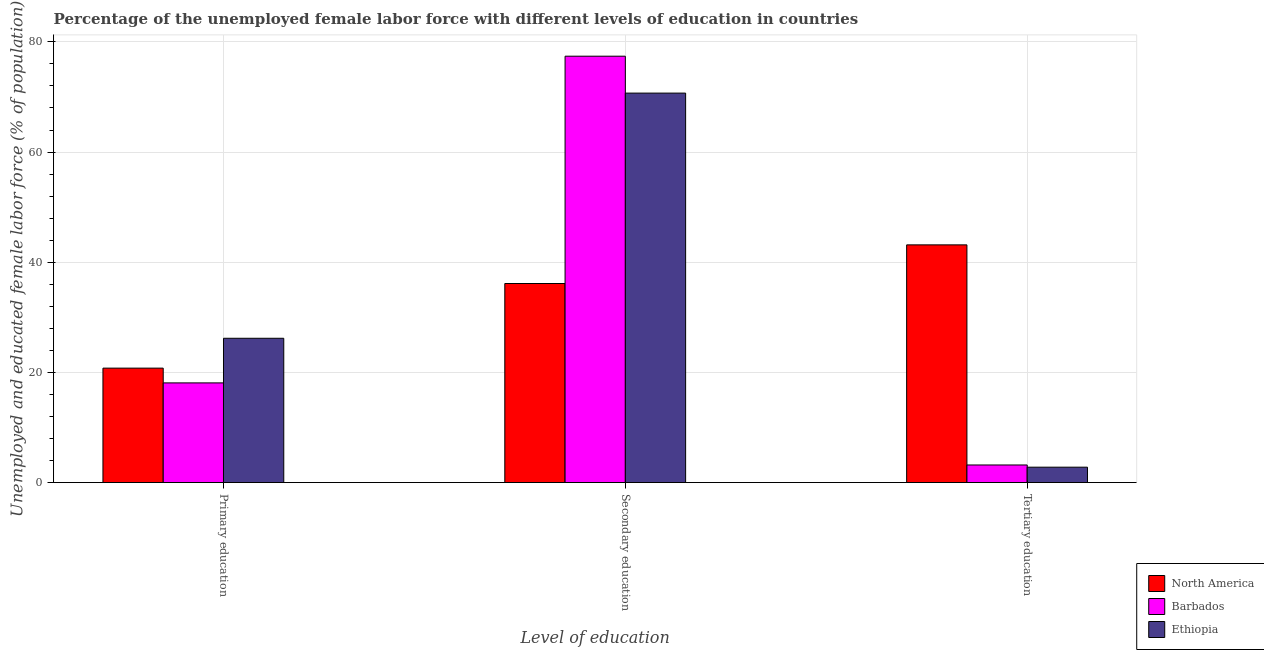How many groups of bars are there?
Your answer should be very brief. 3. How many bars are there on the 1st tick from the left?
Ensure brevity in your answer.  3. What is the label of the 3rd group of bars from the left?
Provide a short and direct response. Tertiary education. What is the percentage of female labor force who received tertiary education in North America?
Offer a very short reply. 43.15. Across all countries, what is the maximum percentage of female labor force who received tertiary education?
Give a very brief answer. 43.15. Across all countries, what is the minimum percentage of female labor force who received primary education?
Keep it short and to the point. 18.1. In which country was the percentage of female labor force who received secondary education maximum?
Keep it short and to the point. Barbados. In which country was the percentage of female labor force who received primary education minimum?
Offer a very short reply. Barbados. What is the total percentage of female labor force who received secondary education in the graph?
Your response must be concise. 184.24. What is the difference between the percentage of female labor force who received secondary education in Barbados and that in Ethiopia?
Make the answer very short. 6.7. What is the difference between the percentage of female labor force who received secondary education in Barbados and the percentage of female labor force who received primary education in Ethiopia?
Make the answer very short. 51.2. What is the average percentage of female labor force who received tertiary education per country?
Offer a very short reply. 16.38. What is the difference between the percentage of female labor force who received tertiary education and percentage of female labor force who received primary education in North America?
Offer a very short reply. 22.37. In how many countries, is the percentage of female labor force who received primary education greater than 32 %?
Your response must be concise. 0. What is the ratio of the percentage of female labor force who received secondary education in Ethiopia to that in Barbados?
Provide a short and direct response. 0.91. What is the difference between the highest and the second highest percentage of female labor force who received primary education?
Offer a terse response. 5.42. What is the difference between the highest and the lowest percentage of female labor force who received primary education?
Your answer should be compact. 8.1. In how many countries, is the percentage of female labor force who received tertiary education greater than the average percentage of female labor force who received tertiary education taken over all countries?
Give a very brief answer. 1. Is the sum of the percentage of female labor force who received tertiary education in North America and Ethiopia greater than the maximum percentage of female labor force who received primary education across all countries?
Your response must be concise. Yes. What does the 2nd bar from the right in Primary education represents?
Offer a terse response. Barbados. How many bars are there?
Provide a short and direct response. 9. Are all the bars in the graph horizontal?
Keep it short and to the point. No. Does the graph contain grids?
Your response must be concise. Yes. How many legend labels are there?
Provide a succinct answer. 3. What is the title of the graph?
Give a very brief answer. Percentage of the unemployed female labor force with different levels of education in countries. Does "Burundi" appear as one of the legend labels in the graph?
Give a very brief answer. No. What is the label or title of the X-axis?
Make the answer very short. Level of education. What is the label or title of the Y-axis?
Your answer should be very brief. Unemployed and educated female labor force (% of population). What is the Unemployed and educated female labor force (% of population) of North America in Primary education?
Provide a succinct answer. 20.78. What is the Unemployed and educated female labor force (% of population) in Barbados in Primary education?
Your answer should be compact. 18.1. What is the Unemployed and educated female labor force (% of population) of Ethiopia in Primary education?
Provide a short and direct response. 26.2. What is the Unemployed and educated female labor force (% of population) in North America in Secondary education?
Provide a short and direct response. 36.14. What is the Unemployed and educated female labor force (% of population) in Barbados in Secondary education?
Keep it short and to the point. 77.4. What is the Unemployed and educated female labor force (% of population) in Ethiopia in Secondary education?
Your answer should be compact. 70.7. What is the Unemployed and educated female labor force (% of population) in North America in Tertiary education?
Offer a terse response. 43.15. What is the Unemployed and educated female labor force (% of population) in Barbados in Tertiary education?
Your response must be concise. 3.2. What is the Unemployed and educated female labor force (% of population) in Ethiopia in Tertiary education?
Give a very brief answer. 2.8. Across all Level of education, what is the maximum Unemployed and educated female labor force (% of population) in North America?
Your response must be concise. 43.15. Across all Level of education, what is the maximum Unemployed and educated female labor force (% of population) in Barbados?
Your response must be concise. 77.4. Across all Level of education, what is the maximum Unemployed and educated female labor force (% of population) of Ethiopia?
Ensure brevity in your answer.  70.7. Across all Level of education, what is the minimum Unemployed and educated female labor force (% of population) of North America?
Keep it short and to the point. 20.78. Across all Level of education, what is the minimum Unemployed and educated female labor force (% of population) in Barbados?
Your answer should be very brief. 3.2. Across all Level of education, what is the minimum Unemployed and educated female labor force (% of population) in Ethiopia?
Ensure brevity in your answer.  2.8. What is the total Unemployed and educated female labor force (% of population) of North America in the graph?
Your response must be concise. 100.07. What is the total Unemployed and educated female labor force (% of population) of Barbados in the graph?
Give a very brief answer. 98.7. What is the total Unemployed and educated female labor force (% of population) of Ethiopia in the graph?
Your answer should be compact. 99.7. What is the difference between the Unemployed and educated female labor force (% of population) of North America in Primary education and that in Secondary education?
Offer a very short reply. -15.36. What is the difference between the Unemployed and educated female labor force (% of population) of Barbados in Primary education and that in Secondary education?
Provide a short and direct response. -59.3. What is the difference between the Unemployed and educated female labor force (% of population) in Ethiopia in Primary education and that in Secondary education?
Your answer should be compact. -44.5. What is the difference between the Unemployed and educated female labor force (% of population) in North America in Primary education and that in Tertiary education?
Provide a succinct answer. -22.37. What is the difference between the Unemployed and educated female labor force (% of population) in Ethiopia in Primary education and that in Tertiary education?
Keep it short and to the point. 23.4. What is the difference between the Unemployed and educated female labor force (% of population) of North America in Secondary education and that in Tertiary education?
Ensure brevity in your answer.  -7.01. What is the difference between the Unemployed and educated female labor force (% of population) in Barbados in Secondary education and that in Tertiary education?
Your answer should be very brief. 74.2. What is the difference between the Unemployed and educated female labor force (% of population) of Ethiopia in Secondary education and that in Tertiary education?
Provide a succinct answer. 67.9. What is the difference between the Unemployed and educated female labor force (% of population) of North America in Primary education and the Unemployed and educated female labor force (% of population) of Barbados in Secondary education?
Make the answer very short. -56.62. What is the difference between the Unemployed and educated female labor force (% of population) of North America in Primary education and the Unemployed and educated female labor force (% of population) of Ethiopia in Secondary education?
Your answer should be compact. -49.92. What is the difference between the Unemployed and educated female labor force (% of population) of Barbados in Primary education and the Unemployed and educated female labor force (% of population) of Ethiopia in Secondary education?
Offer a terse response. -52.6. What is the difference between the Unemployed and educated female labor force (% of population) of North America in Primary education and the Unemployed and educated female labor force (% of population) of Barbados in Tertiary education?
Offer a terse response. 17.58. What is the difference between the Unemployed and educated female labor force (% of population) of North America in Primary education and the Unemployed and educated female labor force (% of population) of Ethiopia in Tertiary education?
Your answer should be very brief. 17.98. What is the difference between the Unemployed and educated female labor force (% of population) of Barbados in Primary education and the Unemployed and educated female labor force (% of population) of Ethiopia in Tertiary education?
Your answer should be very brief. 15.3. What is the difference between the Unemployed and educated female labor force (% of population) in North America in Secondary education and the Unemployed and educated female labor force (% of population) in Barbados in Tertiary education?
Ensure brevity in your answer.  32.94. What is the difference between the Unemployed and educated female labor force (% of population) of North America in Secondary education and the Unemployed and educated female labor force (% of population) of Ethiopia in Tertiary education?
Offer a terse response. 33.34. What is the difference between the Unemployed and educated female labor force (% of population) of Barbados in Secondary education and the Unemployed and educated female labor force (% of population) of Ethiopia in Tertiary education?
Your answer should be compact. 74.6. What is the average Unemployed and educated female labor force (% of population) of North America per Level of education?
Ensure brevity in your answer.  33.36. What is the average Unemployed and educated female labor force (% of population) in Barbados per Level of education?
Give a very brief answer. 32.9. What is the average Unemployed and educated female labor force (% of population) of Ethiopia per Level of education?
Offer a terse response. 33.23. What is the difference between the Unemployed and educated female labor force (% of population) in North America and Unemployed and educated female labor force (% of population) in Barbados in Primary education?
Provide a succinct answer. 2.68. What is the difference between the Unemployed and educated female labor force (% of population) in North America and Unemployed and educated female labor force (% of population) in Ethiopia in Primary education?
Offer a very short reply. -5.42. What is the difference between the Unemployed and educated female labor force (% of population) in Barbados and Unemployed and educated female labor force (% of population) in Ethiopia in Primary education?
Give a very brief answer. -8.1. What is the difference between the Unemployed and educated female labor force (% of population) of North America and Unemployed and educated female labor force (% of population) of Barbados in Secondary education?
Ensure brevity in your answer.  -41.26. What is the difference between the Unemployed and educated female labor force (% of population) of North America and Unemployed and educated female labor force (% of population) of Ethiopia in Secondary education?
Give a very brief answer. -34.56. What is the difference between the Unemployed and educated female labor force (% of population) in North America and Unemployed and educated female labor force (% of population) in Barbados in Tertiary education?
Offer a very short reply. 39.95. What is the difference between the Unemployed and educated female labor force (% of population) of North America and Unemployed and educated female labor force (% of population) of Ethiopia in Tertiary education?
Offer a very short reply. 40.35. What is the difference between the Unemployed and educated female labor force (% of population) of Barbados and Unemployed and educated female labor force (% of population) of Ethiopia in Tertiary education?
Give a very brief answer. 0.4. What is the ratio of the Unemployed and educated female labor force (% of population) in North America in Primary education to that in Secondary education?
Provide a short and direct response. 0.57. What is the ratio of the Unemployed and educated female labor force (% of population) in Barbados in Primary education to that in Secondary education?
Make the answer very short. 0.23. What is the ratio of the Unemployed and educated female labor force (% of population) in Ethiopia in Primary education to that in Secondary education?
Ensure brevity in your answer.  0.37. What is the ratio of the Unemployed and educated female labor force (% of population) in North America in Primary education to that in Tertiary education?
Your answer should be very brief. 0.48. What is the ratio of the Unemployed and educated female labor force (% of population) in Barbados in Primary education to that in Tertiary education?
Provide a succinct answer. 5.66. What is the ratio of the Unemployed and educated female labor force (% of population) of Ethiopia in Primary education to that in Tertiary education?
Make the answer very short. 9.36. What is the ratio of the Unemployed and educated female labor force (% of population) of North America in Secondary education to that in Tertiary education?
Make the answer very short. 0.84. What is the ratio of the Unemployed and educated female labor force (% of population) of Barbados in Secondary education to that in Tertiary education?
Provide a short and direct response. 24.19. What is the ratio of the Unemployed and educated female labor force (% of population) in Ethiopia in Secondary education to that in Tertiary education?
Offer a very short reply. 25.25. What is the difference between the highest and the second highest Unemployed and educated female labor force (% of population) of North America?
Offer a very short reply. 7.01. What is the difference between the highest and the second highest Unemployed and educated female labor force (% of population) in Barbados?
Offer a very short reply. 59.3. What is the difference between the highest and the second highest Unemployed and educated female labor force (% of population) of Ethiopia?
Offer a very short reply. 44.5. What is the difference between the highest and the lowest Unemployed and educated female labor force (% of population) in North America?
Keep it short and to the point. 22.37. What is the difference between the highest and the lowest Unemployed and educated female labor force (% of population) in Barbados?
Offer a terse response. 74.2. What is the difference between the highest and the lowest Unemployed and educated female labor force (% of population) of Ethiopia?
Provide a short and direct response. 67.9. 